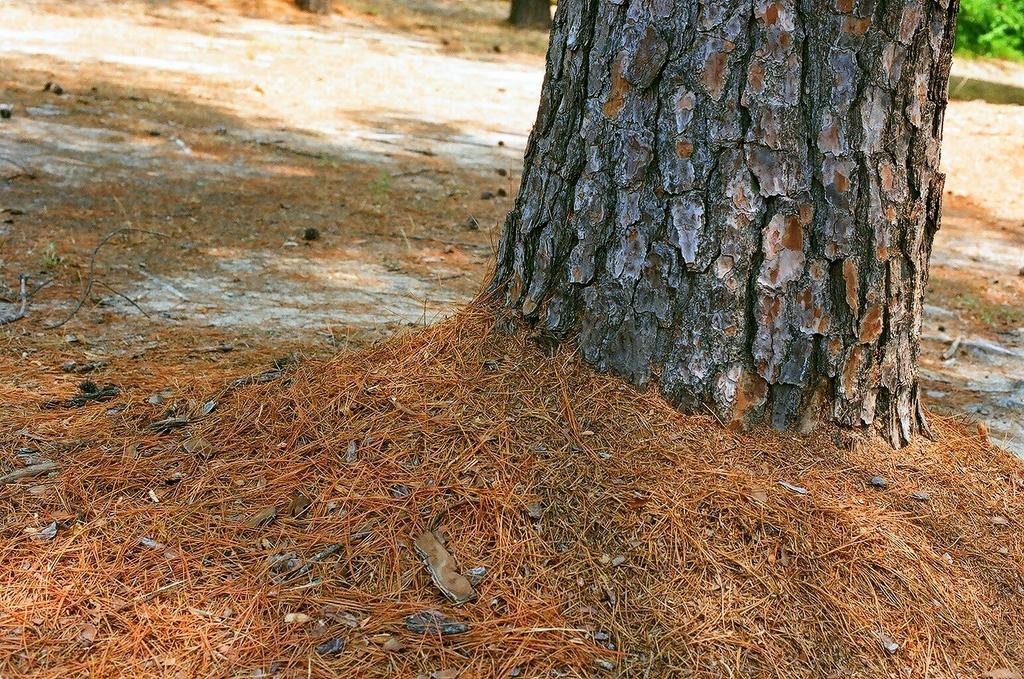What is the main subject of the image? The main subject of the image is a tree trunk. What else can be seen in the image besides the tree trunk? There are plants and dirt visible on the ground in the image. What type of car is parked next to the tree trunk in the image? There is no car present in the image; it only features a tree trunk, plants, and dirt on the ground. 